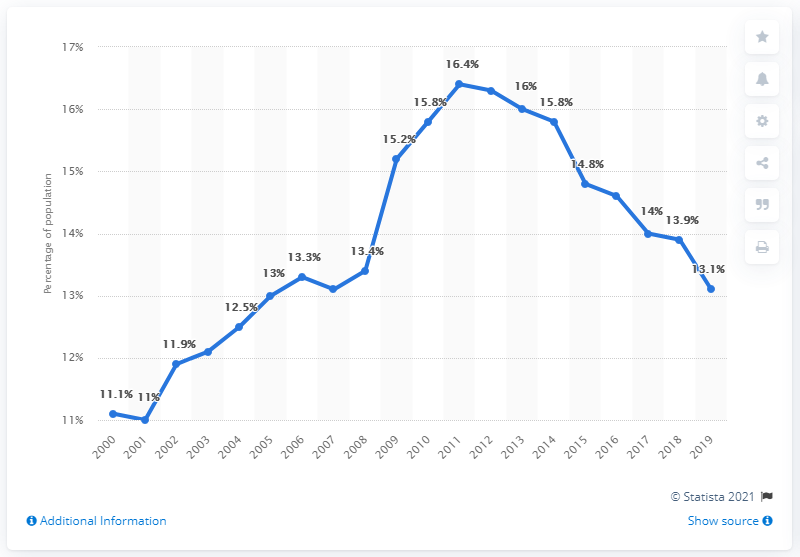Mention a couple of crucial points in this snapshot. According to data collected from 2000 to 2019, the highest poverty rate in Ohio was 5.4%, while the lowest poverty rate was 5.4%. According to data from the year 2018, the poverty rate in the state of Ohio was 13.9%. 